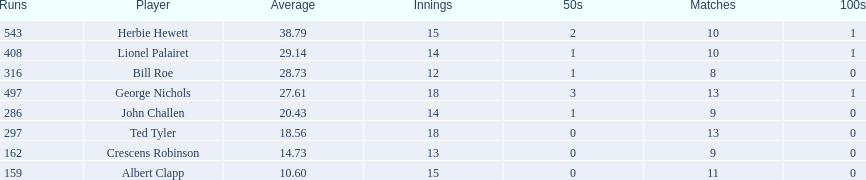Who are the players in somerset county cricket club in 1890? Herbie Hewett, Lionel Palairet, Bill Roe, George Nichols, John Challen, Ted Tyler, Crescens Robinson, Albert Clapp. Who is the only player to play less than 13 innings? Bill Roe. 